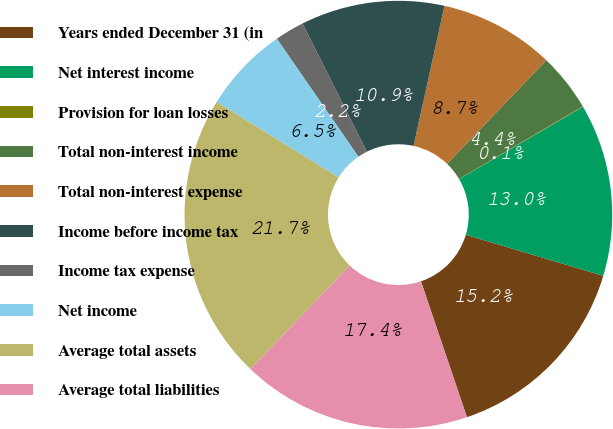<chart> <loc_0><loc_0><loc_500><loc_500><pie_chart><fcel>Years ended December 31 (in<fcel>Net interest income<fcel>Provision for loan losses<fcel>Total non-interest income<fcel>Total non-interest expense<fcel>Income before income tax<fcel>Income tax expense<fcel>Net income<fcel>Average total assets<fcel>Average total liabilities<nl><fcel>15.19%<fcel>13.03%<fcel>0.05%<fcel>4.38%<fcel>8.7%<fcel>10.86%<fcel>2.22%<fcel>6.54%<fcel>21.68%<fcel>17.35%<nl></chart> 